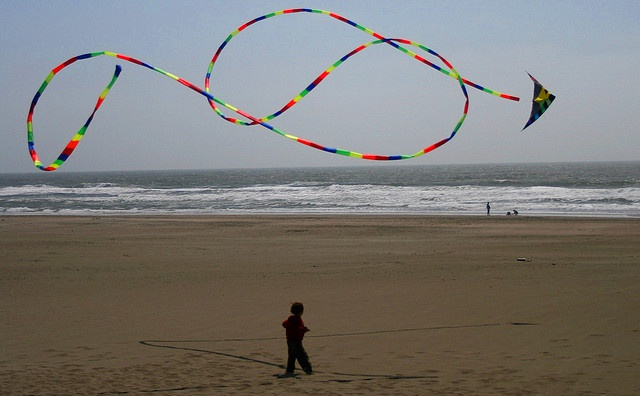Describe the objects in this image and their specific colors. I can see kite in darkgray, navy, red, and black tones, people in darkgray, black, gray, and maroon tones, people in darkgray, black, and gray tones, and people in darkgray, black, and gray tones in this image. 